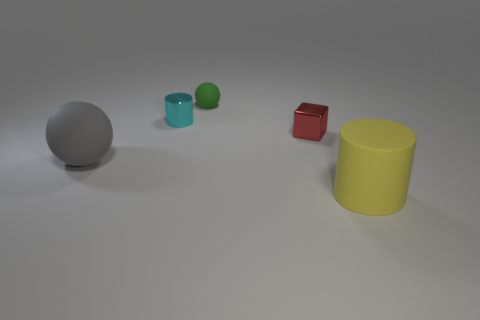Add 5 gray matte objects. How many objects exist? 10 Subtract all spheres. How many objects are left? 3 Add 4 cyan things. How many cyan things exist? 5 Subtract 0 cyan blocks. How many objects are left? 5 Subtract all yellow cylinders. Subtract all red matte cylinders. How many objects are left? 4 Add 4 gray matte balls. How many gray matte balls are left? 5 